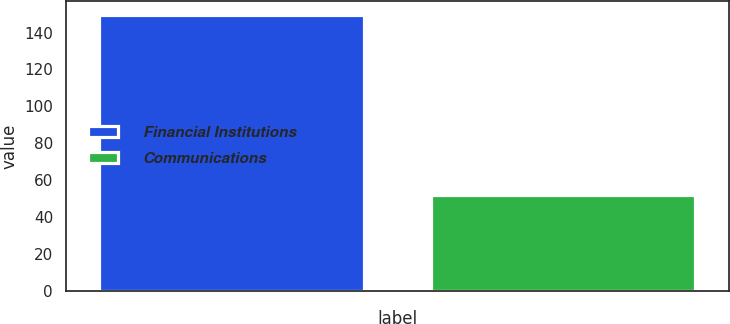<chart> <loc_0><loc_0><loc_500><loc_500><bar_chart><fcel>Financial Institutions<fcel>Communications<nl><fcel>149.7<fcel>51.9<nl></chart> 